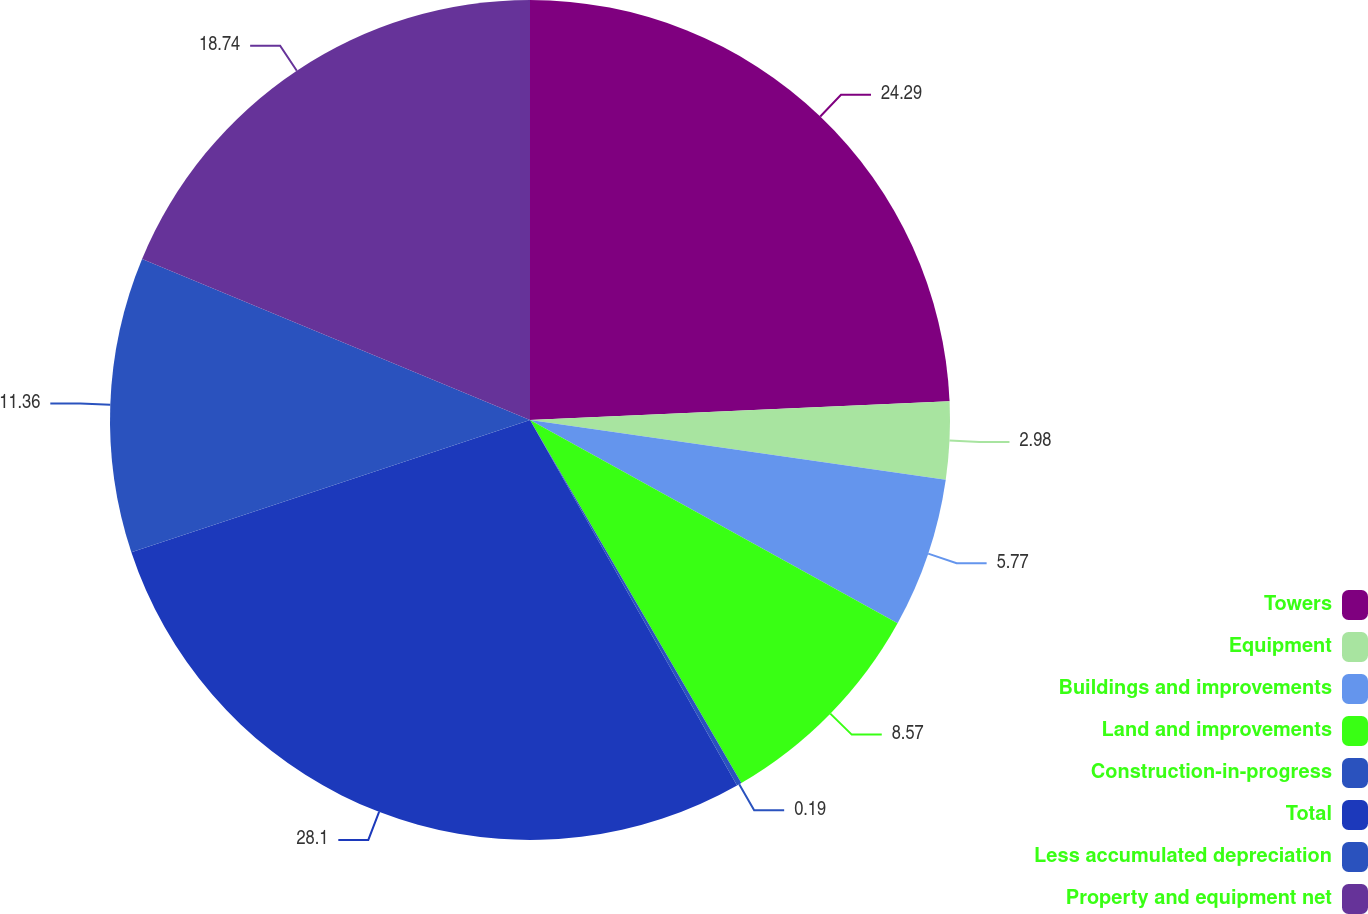Convert chart to OTSL. <chart><loc_0><loc_0><loc_500><loc_500><pie_chart><fcel>Towers<fcel>Equipment<fcel>Buildings and improvements<fcel>Land and improvements<fcel>Construction-in-progress<fcel>Total<fcel>Less accumulated depreciation<fcel>Property and equipment net<nl><fcel>24.29%<fcel>2.98%<fcel>5.77%<fcel>8.57%<fcel>0.19%<fcel>28.11%<fcel>11.36%<fcel>18.74%<nl></chart> 